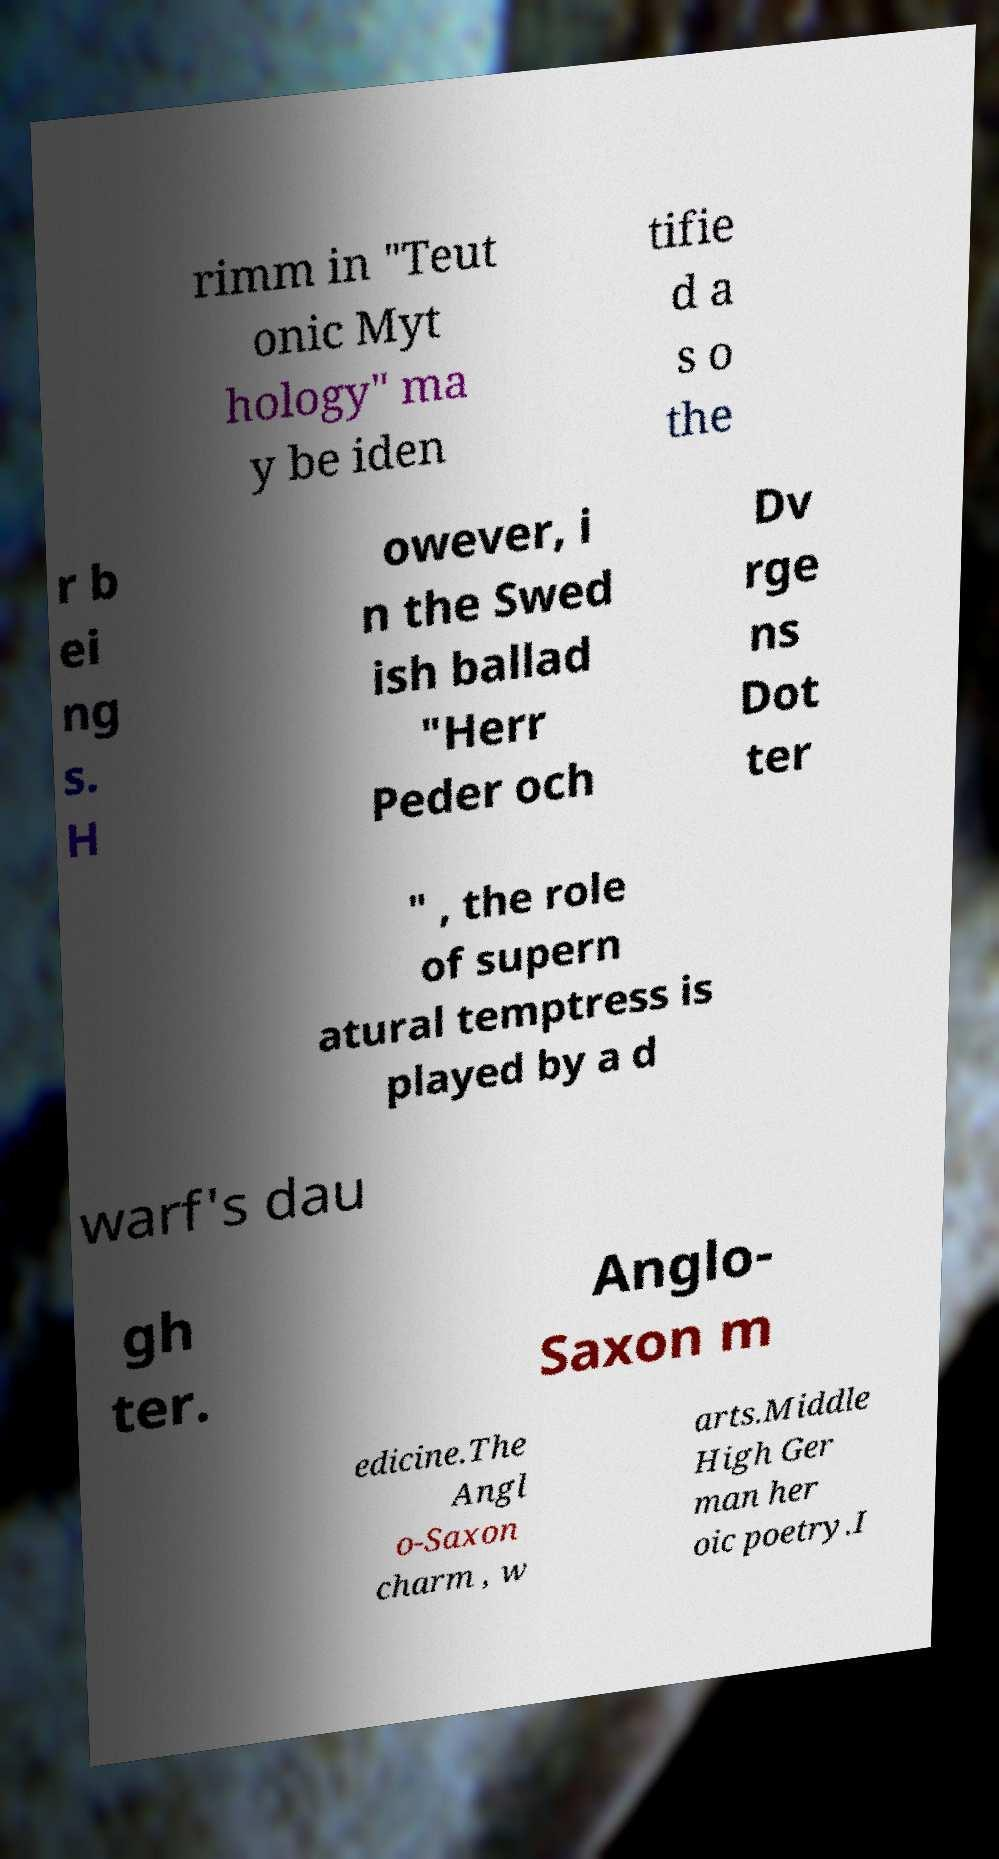Please read and relay the text visible in this image. What does it say? rimm in "Teut onic Myt hology" ma y be iden tifie d a s o the r b ei ng s. H owever, i n the Swed ish ballad "Herr Peder och Dv rge ns Dot ter " , the role of supern atural temptress is played by a d warf's dau gh ter. Anglo- Saxon m edicine.The Angl o-Saxon charm , w arts.Middle High Ger man her oic poetry.I 